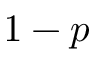<formula> <loc_0><loc_0><loc_500><loc_500>1 - p</formula> 